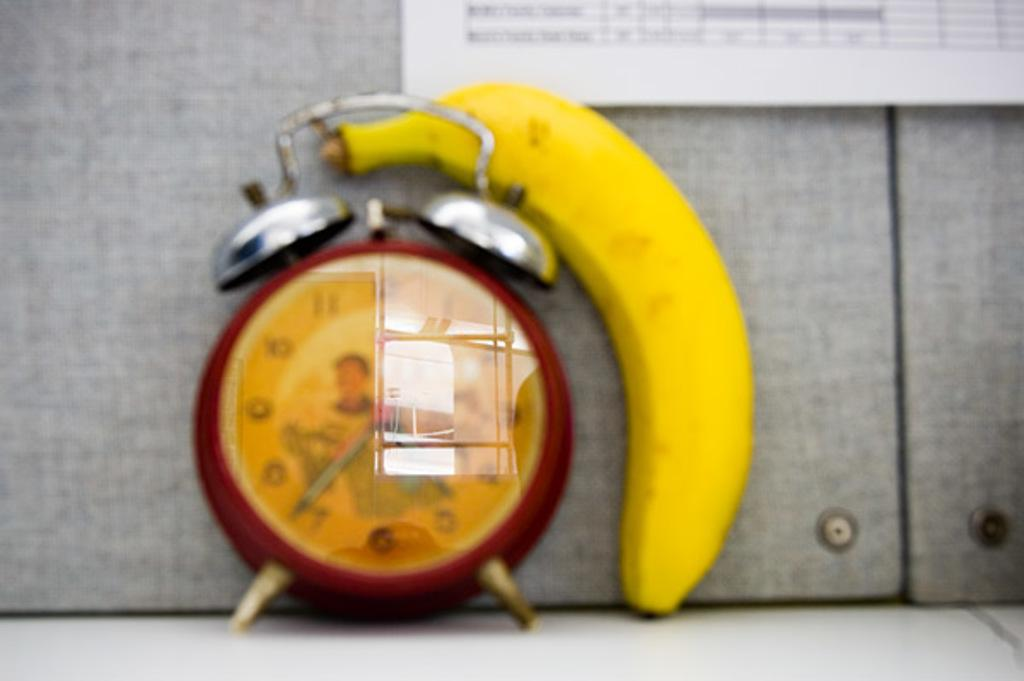What object is present in the image that is typically used for waking up? There is an alarm clock in the image. What is located on the floor in the image? There is a banana on the floor in the image. How many insects can be seen crawling on the bottle in the image? There is no bottle present in the image, and therefore no insects can be seen crawling on it. 